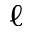Convert formula to latex. <formula><loc_0><loc_0><loc_500><loc_500>\ell</formula> 